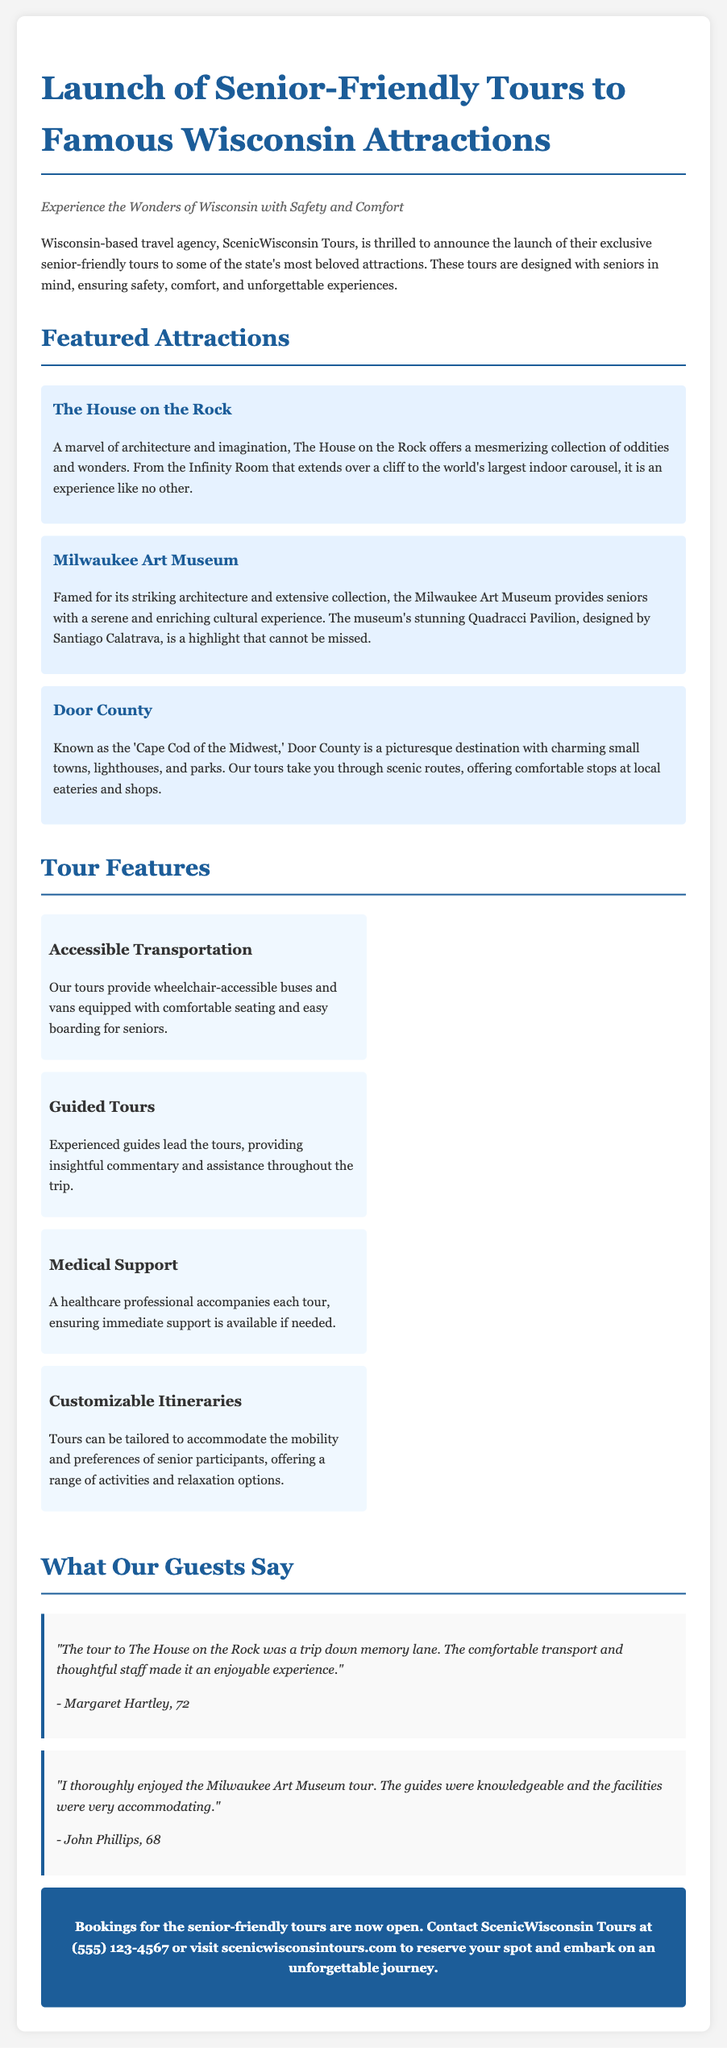What is the name of the travel agency? The travel agency mentioned in the document is ScenicWisconsin Tours.
Answer: ScenicWisconsin Tours How many attractions are featured in the tours? The document lists three attractions, namely The House on the Rock, Milwaukee Art Museum, and Door County.
Answer: Three What is one feature of the tours related to transport? The document states that the tours provide wheelchair-accessible buses and vans.
Answer: Wheelchair-accessible buses Who accompanies each tour for medical support? A healthcare professional is mentioned as accompanying each tour for medical support.
Answer: Healthcare professional What is one testimonial about The House on the Rock tour? The testimonial from Margaret Hartley mentions a positive experience with comfortable transport and thoughtful staff.
Answer: Comfortable transport and thoughtful staff What is the contact number for ScenicWisconsin Tours? The document provides a contact number of (555) 123-4567 for bookings.
Answer: (555) 123-4567 What is the primary focus of these tours? The primary focus of these tours is to ensure safety, comfort, and unforgettable experiences for seniors.
Answer: Safety and comfort What architectural feature is highlighted at the Milwaukee Art Museum? The stunning Quadracci Pavilion designed by Santiago Calatrava is highlighted in the document.
Answer: Quadracci Pavilion 